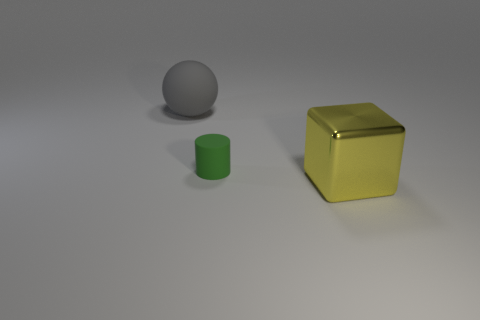Is there anything else that is made of the same material as the large yellow cube?
Your response must be concise. No. Is there a gray sphere made of the same material as the small cylinder?
Offer a very short reply. Yes. The big object that is behind the object to the right of the matte object in front of the gray thing is what shape?
Offer a very short reply. Sphere. Does the sphere have the same size as the thing that is in front of the green cylinder?
Offer a very short reply. Yes. There is a thing that is right of the large gray object and behind the yellow cube; what is its shape?
Keep it short and to the point. Cylinder. What number of small things are either gray spheres or red metal cylinders?
Offer a terse response. 0. Are there an equal number of rubber spheres on the right side of the big metal object and large gray balls that are in front of the green cylinder?
Your answer should be very brief. Yes. Are there the same number of yellow metal objects to the left of the green rubber cylinder and blue shiny blocks?
Your response must be concise. Yes. Do the yellow shiny cube and the gray matte object have the same size?
Your answer should be very brief. Yes. What material is the thing that is both to the left of the metallic block and in front of the gray thing?
Keep it short and to the point. Rubber. 